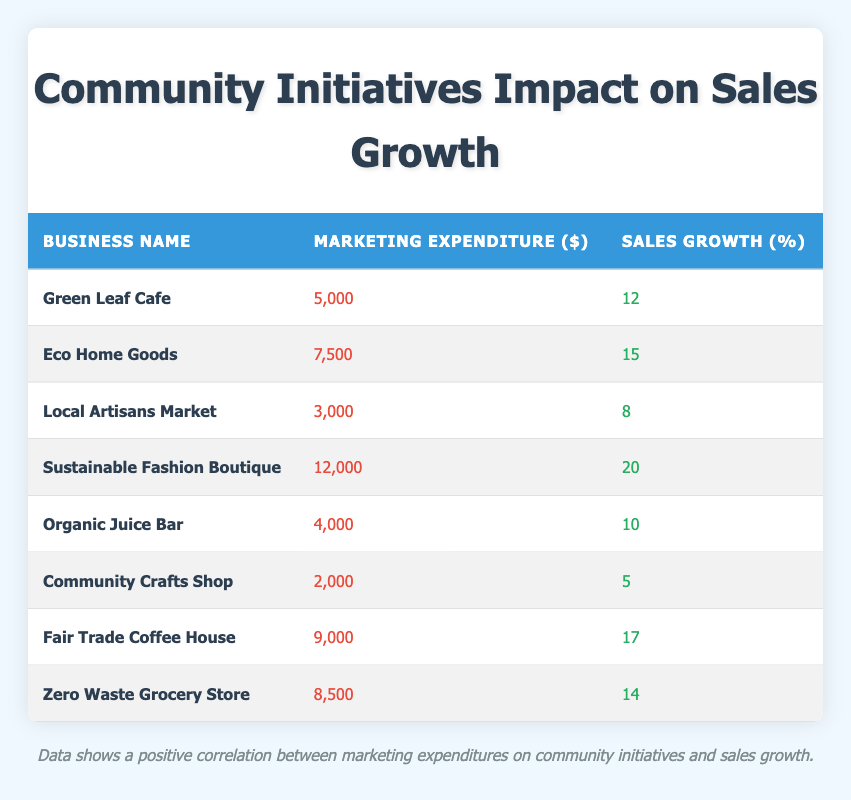What is the marketing expenditure of Sustainable Fashion Boutique? The table lists the marketing expenditure for each business. For Sustainable Fashion Boutique, the expenditure is noted as 12,000 dollars.
Answer: 12,000 What is the sales growth percentage for Fair Trade Coffee House? By checking the table, Fair Trade Coffee House's sales growth percentage is explicitly listed as 17 percent.
Answer: 17 Which business has the highest marketing expenditure? Reviewing the marketing expenditures across all businesses, Sustainable Fashion Boutique has the highest amount listed at 12,000 dollars.
Answer: Sustainable Fashion Boutique What is the average sales growth of all the businesses? To find the average, we first add all sales growth percentages: 12 + 15 + 8 + 20 + 10 + 5 + 17 + 14 = 101. With eight businesses, we divide by 8 to get the average: 101 / 8 = 12.625.
Answer: 12.625 Is there a business with a marketing expenditure of 2,000 dollars? The table indicates that Community Crafts Shop has a marketing expenditure of 2,000 dollars.
Answer: Yes How does the sales growth of the business with the lowest marketing expenditure compare to the business with the highest marketing expenditure? The business with the lowest expenditure is Community Crafts Shop at 2,000 dollars with a sales growth of 5 percent. The highest expenditure is Sustainable Fashion Boutique at 12,000 dollars with a sales growth of 20 percent. The difference in sales growth is 20 - 5 = 15.
Answer: 15 What is the relationship between marketing expenditure and sales growth for businesses with expenditures over 8,000 dollars? The businesses with expenditures over 8,000 dollars are Sustainable Fashion Boutique (12,000 dollars, 20 percent), Fair Trade Coffee House (9,000 dollars, 17 percent), and Zero Waste Grocery Store (8,500 dollars, 14 percent). All these businesses show a positive correlation: higher marketing expenditures lead to higher sales growth percentages.
Answer: Positive correlation Which business has a sales growth greater than 15 percent and what is its marketing expenditure? Only Sustainable Fashion Boutique (20 percent) and Fair Trade Coffee House (17 percent) have sales growth greater than 15 percent. Their marketing expenditures are 12,000 dollars and 9,000 dollars respectively.
Answer: Sustainable Fashion Boutique - 12,000 dollars; Fair Trade Coffee House - 9,000 dollars 